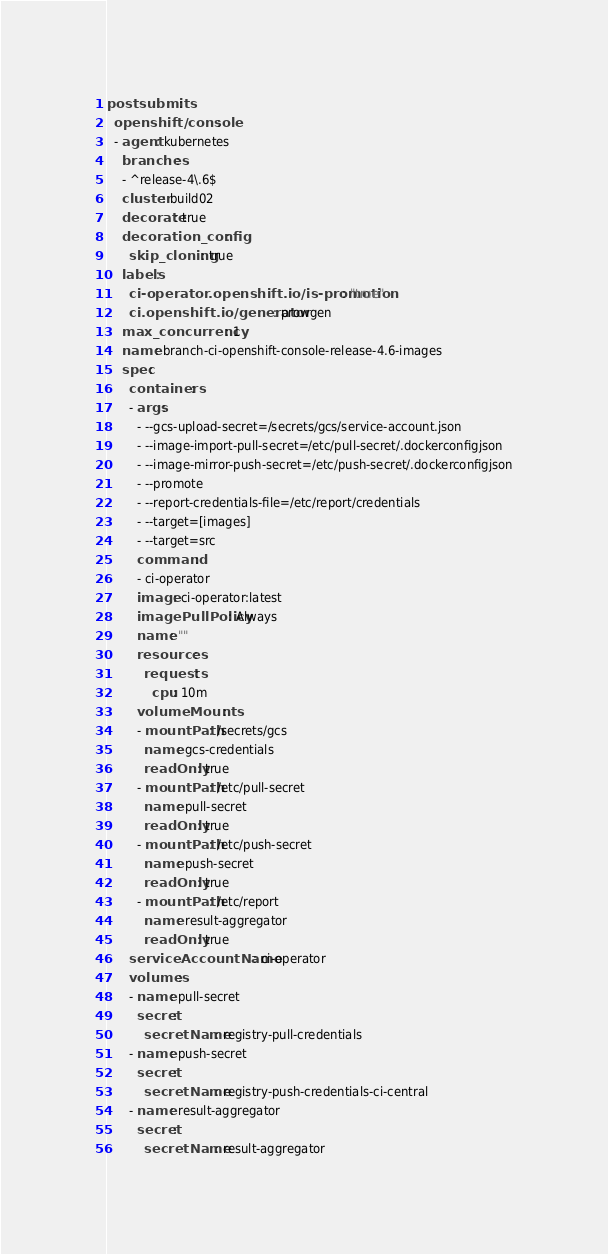<code> <loc_0><loc_0><loc_500><loc_500><_YAML_>postsubmits:
  openshift/console:
  - agent: kubernetes
    branches:
    - ^release-4\.6$
    cluster: build02
    decorate: true
    decoration_config:
      skip_cloning: true
    labels:
      ci-operator.openshift.io/is-promotion: "true"
      ci.openshift.io/generator: prowgen
    max_concurrency: 1
    name: branch-ci-openshift-console-release-4.6-images
    spec:
      containers:
      - args:
        - --gcs-upload-secret=/secrets/gcs/service-account.json
        - --image-import-pull-secret=/etc/pull-secret/.dockerconfigjson
        - --image-mirror-push-secret=/etc/push-secret/.dockerconfigjson
        - --promote
        - --report-credentials-file=/etc/report/credentials
        - --target=[images]
        - --target=src
        command:
        - ci-operator
        image: ci-operator:latest
        imagePullPolicy: Always
        name: ""
        resources:
          requests:
            cpu: 10m
        volumeMounts:
        - mountPath: /secrets/gcs
          name: gcs-credentials
          readOnly: true
        - mountPath: /etc/pull-secret
          name: pull-secret
          readOnly: true
        - mountPath: /etc/push-secret
          name: push-secret
          readOnly: true
        - mountPath: /etc/report
          name: result-aggregator
          readOnly: true
      serviceAccountName: ci-operator
      volumes:
      - name: pull-secret
        secret:
          secretName: registry-pull-credentials
      - name: push-secret
        secret:
          secretName: registry-push-credentials-ci-central
      - name: result-aggregator
        secret:
          secretName: result-aggregator
</code> 